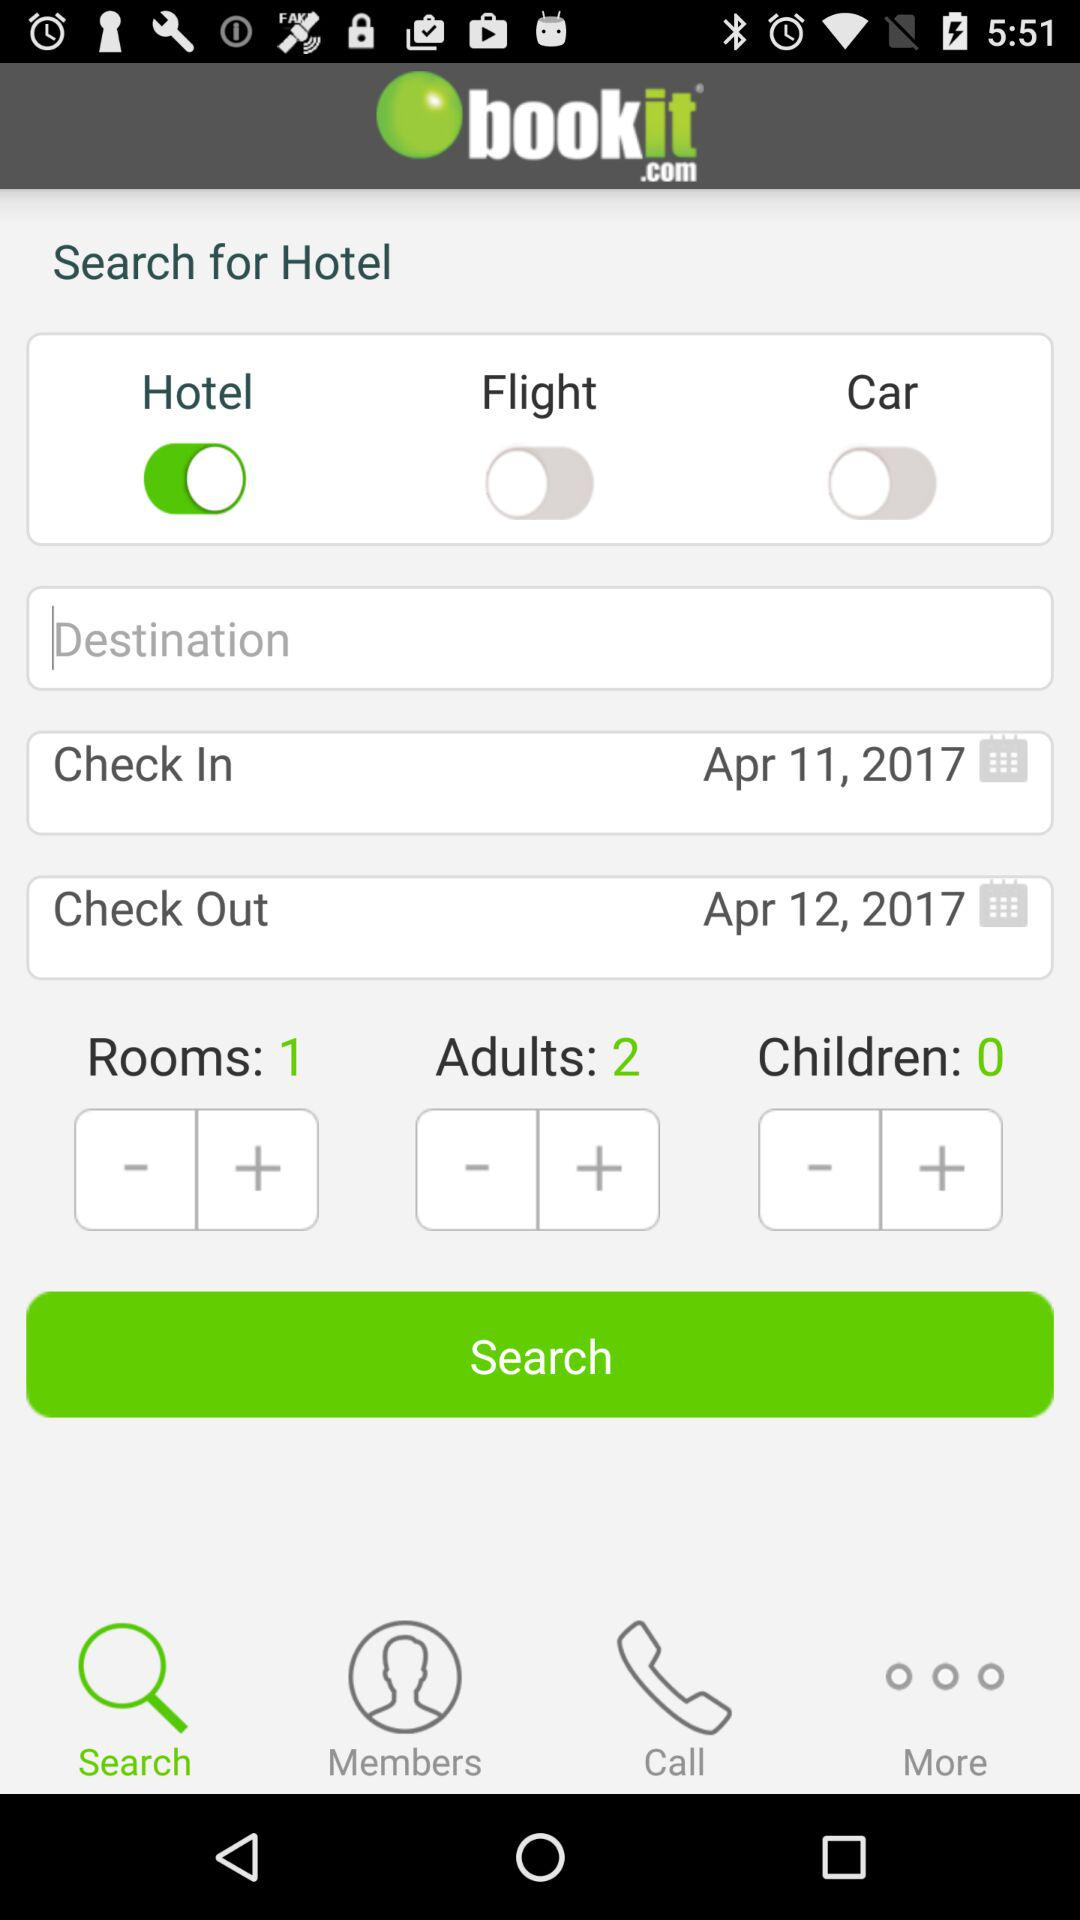How many adults are shown on the screen? The number of adults shown on the screen is 2. 